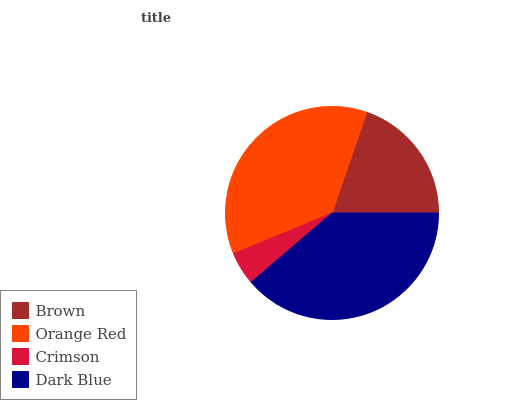Is Crimson the minimum?
Answer yes or no. Yes. Is Dark Blue the maximum?
Answer yes or no. Yes. Is Orange Red the minimum?
Answer yes or no. No. Is Orange Red the maximum?
Answer yes or no. No. Is Orange Red greater than Brown?
Answer yes or no. Yes. Is Brown less than Orange Red?
Answer yes or no. Yes. Is Brown greater than Orange Red?
Answer yes or no. No. Is Orange Red less than Brown?
Answer yes or no. No. Is Orange Red the high median?
Answer yes or no. Yes. Is Brown the low median?
Answer yes or no. Yes. Is Brown the high median?
Answer yes or no. No. Is Orange Red the low median?
Answer yes or no. No. 